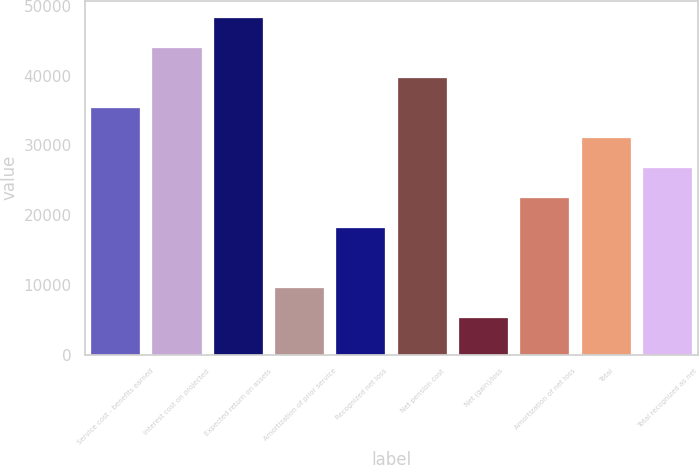Convert chart to OTSL. <chart><loc_0><loc_0><loc_500><loc_500><bar_chart><fcel>Service cost - benefits earned<fcel>Interest cost on projected<fcel>Expected return on assets<fcel>Amortization of prior service<fcel>Recognized net loss<fcel>Net pension cost<fcel>Net (gain)/loss<fcel>Amortization of net loss<fcel>Total<fcel>Total recognized as net<nl><fcel>35408<fcel>44037<fcel>48351.5<fcel>9521<fcel>18150<fcel>39722.5<fcel>5206.5<fcel>22464.5<fcel>31093.5<fcel>26779<nl></chart> 